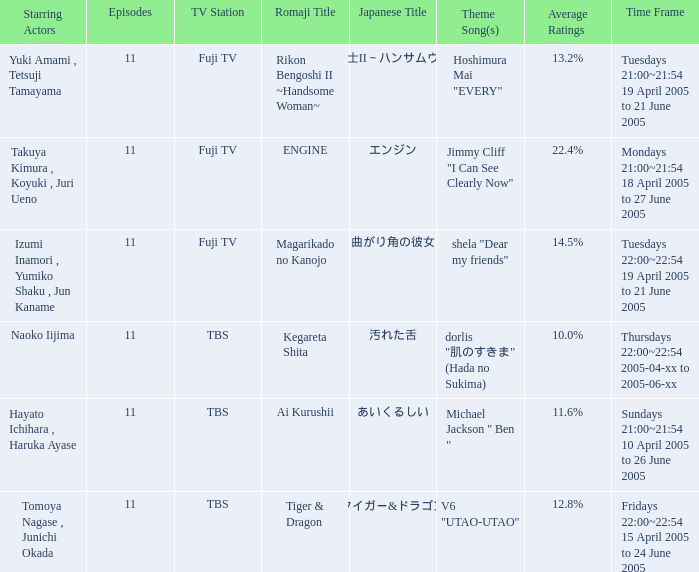What is the theme song for Magarikado no Kanojo? Shela "dear my friends". 